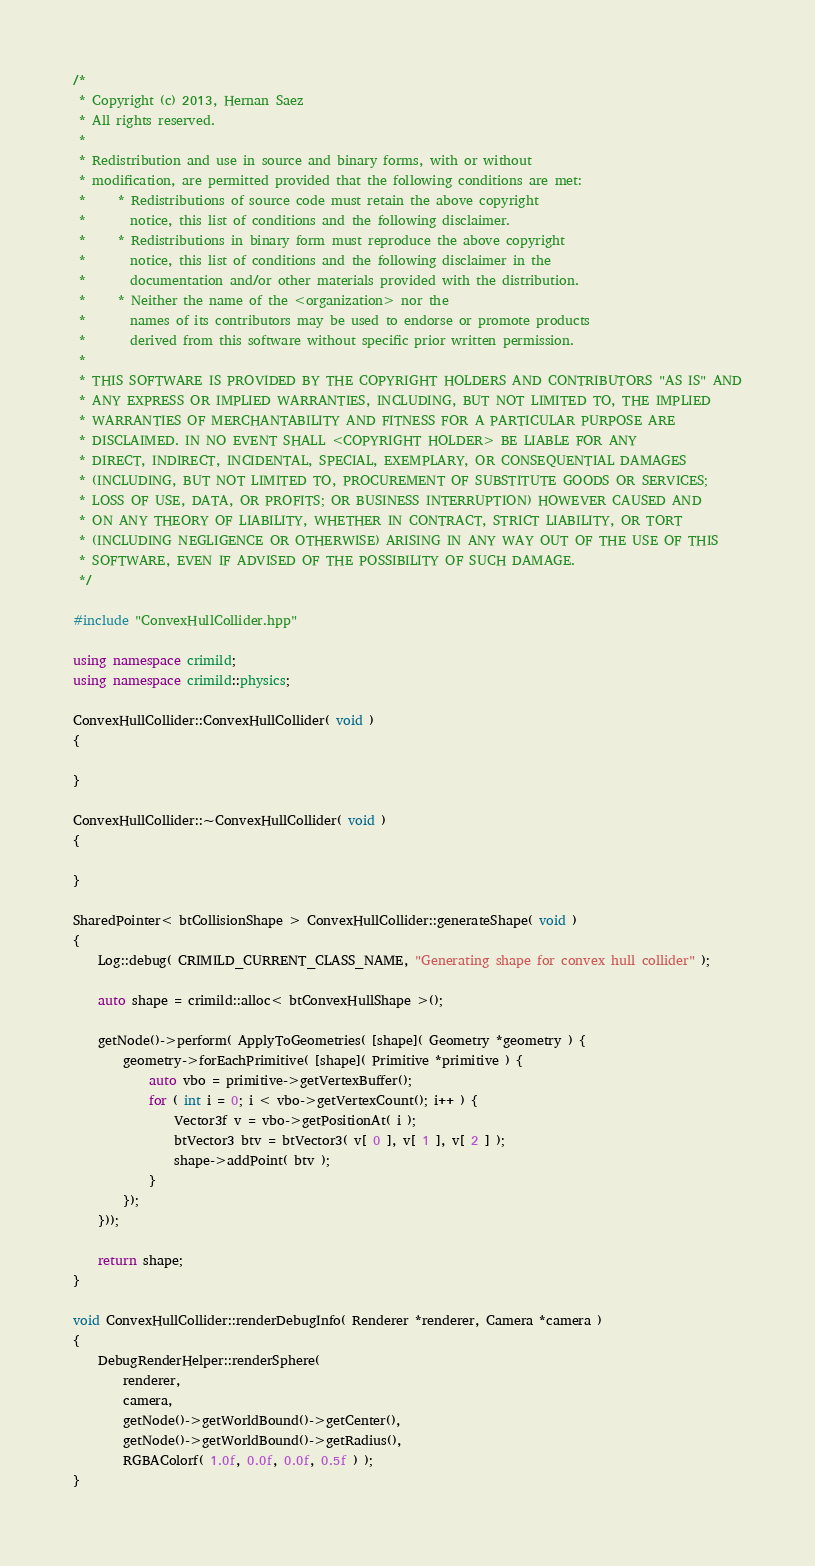<code> <loc_0><loc_0><loc_500><loc_500><_C++_>/*
 * Copyright (c) 2013, Hernan Saez
 * All rights reserved.
 * 
 * Redistribution and use in source and binary forms, with or without
 * modification, are permitted provided that the following conditions are met:
 *     * Redistributions of source code must retain the above copyright
 *       notice, this list of conditions and the following disclaimer.
 *     * Redistributions in binary form must reproduce the above copyright
 *       notice, this list of conditions and the following disclaimer in the
 *       documentation and/or other materials provided with the distribution.
 *     * Neither the name of the <organization> nor the
 *       names of its contributors may be used to endorse or promote products
 *       derived from this software without specific prior written permission.
 * 
 * THIS SOFTWARE IS PROVIDED BY THE COPYRIGHT HOLDERS AND CONTRIBUTORS "AS IS" AND
 * ANY EXPRESS OR IMPLIED WARRANTIES, INCLUDING, BUT NOT LIMITED TO, THE IMPLIED
 * WARRANTIES OF MERCHANTABILITY AND FITNESS FOR A PARTICULAR PURPOSE ARE
 * DISCLAIMED. IN NO EVENT SHALL <COPYRIGHT HOLDER> BE LIABLE FOR ANY
 * DIRECT, INDIRECT, INCIDENTAL, SPECIAL, EXEMPLARY, OR CONSEQUENTIAL DAMAGES
 * (INCLUDING, BUT NOT LIMITED TO, PROCUREMENT OF SUBSTITUTE GOODS OR SERVICES;
 * LOSS OF USE, DATA, OR PROFITS; OR BUSINESS INTERRUPTION) HOWEVER CAUSED AND
 * ON ANY THEORY OF LIABILITY, WHETHER IN CONTRACT, STRICT LIABILITY, OR TORT
 * (INCLUDING NEGLIGENCE OR OTHERWISE) ARISING IN ANY WAY OUT OF THE USE OF THIS
 * SOFTWARE, EVEN IF ADVISED OF THE POSSIBILITY OF SUCH DAMAGE.
 */

#include "ConvexHullCollider.hpp"

using namespace crimild;
using namespace crimild::physics;

ConvexHullCollider::ConvexHullCollider( void )
{

}

ConvexHullCollider::~ConvexHullCollider( void )
{

}

SharedPointer< btCollisionShape > ConvexHullCollider::generateShape( void ) 
{
    Log::debug( CRIMILD_CURRENT_CLASS_NAME, "Generating shape for convex hull collider" );

	auto shape = crimild::alloc< btConvexHullShape >();

	getNode()->perform( ApplyToGeometries( [shape]( Geometry *geometry ) {
		geometry->forEachPrimitive( [shape]( Primitive *primitive ) {
			auto vbo = primitive->getVertexBuffer();
			for ( int i = 0; i < vbo->getVertexCount(); i++ ) {
				Vector3f v = vbo->getPositionAt( i );
				btVector3 btv = btVector3( v[ 0 ], v[ 1 ], v[ 2 ] );
        		shape->addPoint( btv );
			}
		});
	}));

	return shape;
}

void ConvexHullCollider::renderDebugInfo( Renderer *renderer, Camera *camera )
{
	DebugRenderHelper::renderSphere( 
		renderer, 
		camera, 
		getNode()->getWorldBound()->getCenter(), 
		getNode()->getWorldBound()->getRadius(), 
		RGBAColorf( 1.0f, 0.0f, 0.0f, 0.5f ) );
}

</code> 